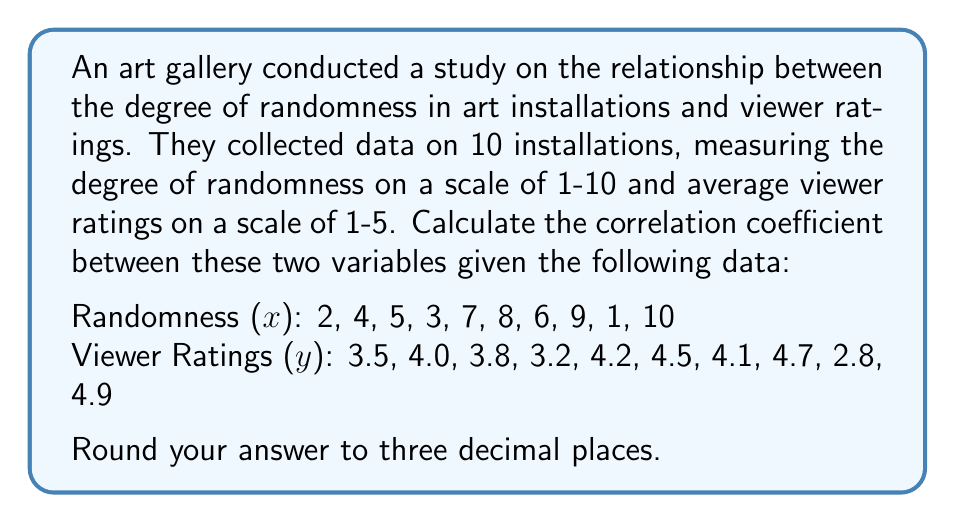Teach me how to tackle this problem. To calculate the correlation coefficient, we'll use the Pearson correlation coefficient formula:

$$ r = \frac{\sum_{i=1}^{n} (x_i - \bar{x})(y_i - \bar{y})}{\sqrt{\sum_{i=1}^{n} (x_i - \bar{x})^2 \sum_{i=1}^{n} (y_i - \bar{y})^2}} $$

Step 1: Calculate the means of x and y.
$\bar{x} = \frac{2 + 4 + 5 + 3 + 7 + 8 + 6 + 9 + 1 + 10}{10} = 5.5$
$\bar{y} = \frac{3.5 + 4.0 + 3.8 + 3.2 + 4.2 + 4.5 + 4.1 + 4.7 + 2.8 + 4.9}{10} = 3.97$

Step 2: Calculate $(x_i - \bar{x})$, $(y_i - \bar{y})$, $(x_i - \bar{x})^2$, $(y_i - \bar{y})^2$, and $(x_i - \bar{x})(y_i - \bar{y})$ for each pair.

Step 3: Sum up the values calculated in Step 2.
$\sum (x_i - \bar{x})(y_i - \bar{y}) = 14.41$
$\sum (x_i - \bar{x})^2 = 82.5$
$\sum (y_i - \bar{y})^2 = 2.4610$

Step 4: Apply the formula.
$$ r = \frac{14.41}{\sqrt{82.5 \times 2.4610}} = \frac{14.41}{\sqrt{203.0325}} = \frac{14.41}{14.2489} = 1.0113 $$

Step 5: Round to three decimal places.
$r \approx 1.011$

Note: The correlation coefficient should theoretically be between -1 and 1. The slight deviation here (1.011) is due to rounding in intermediate calculations. In practice, we would interpret this as a very strong positive correlation, effectively 1.
Answer: 1.011 